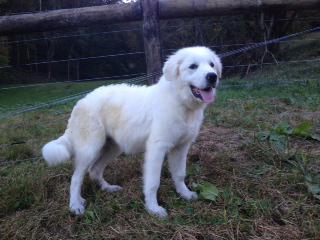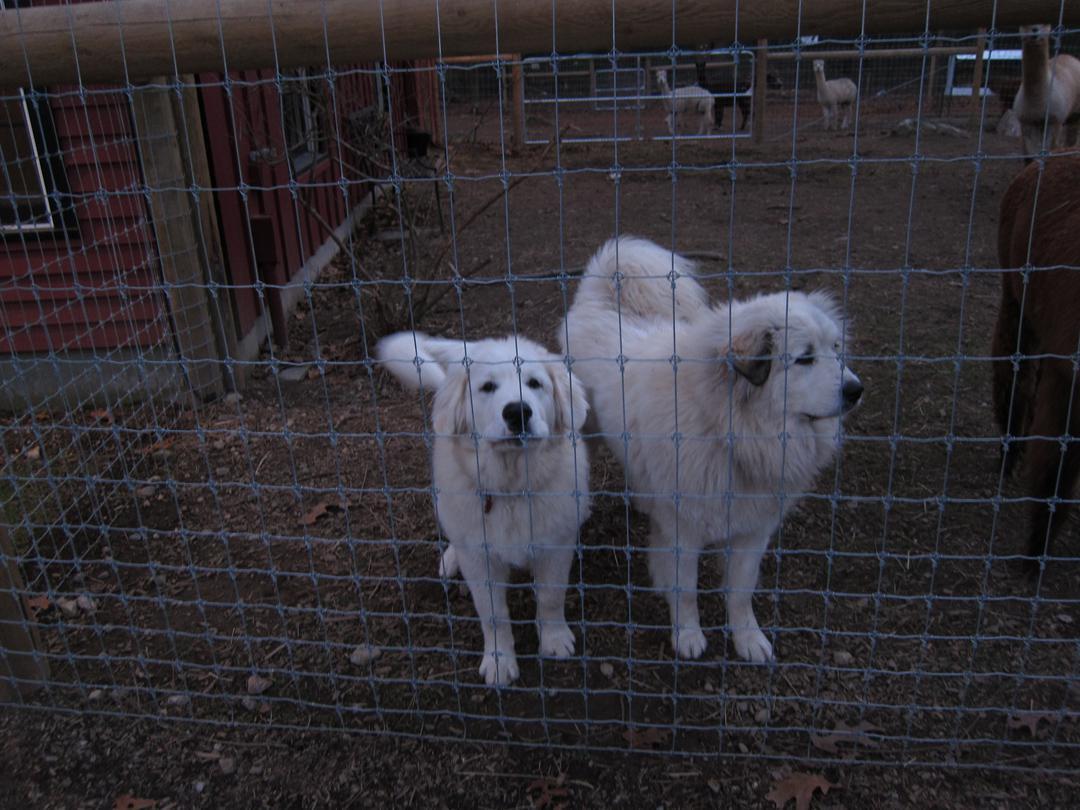The first image is the image on the left, the second image is the image on the right. For the images shown, is this caption "in both pairs the dogs are on a natural outdoor surface" true? Answer yes or no. Yes. The first image is the image on the left, the second image is the image on the right. Given the left and right images, does the statement "There is a white dog in each photo looking straight ahead enjoying it's time outside." hold true? Answer yes or no. No. 